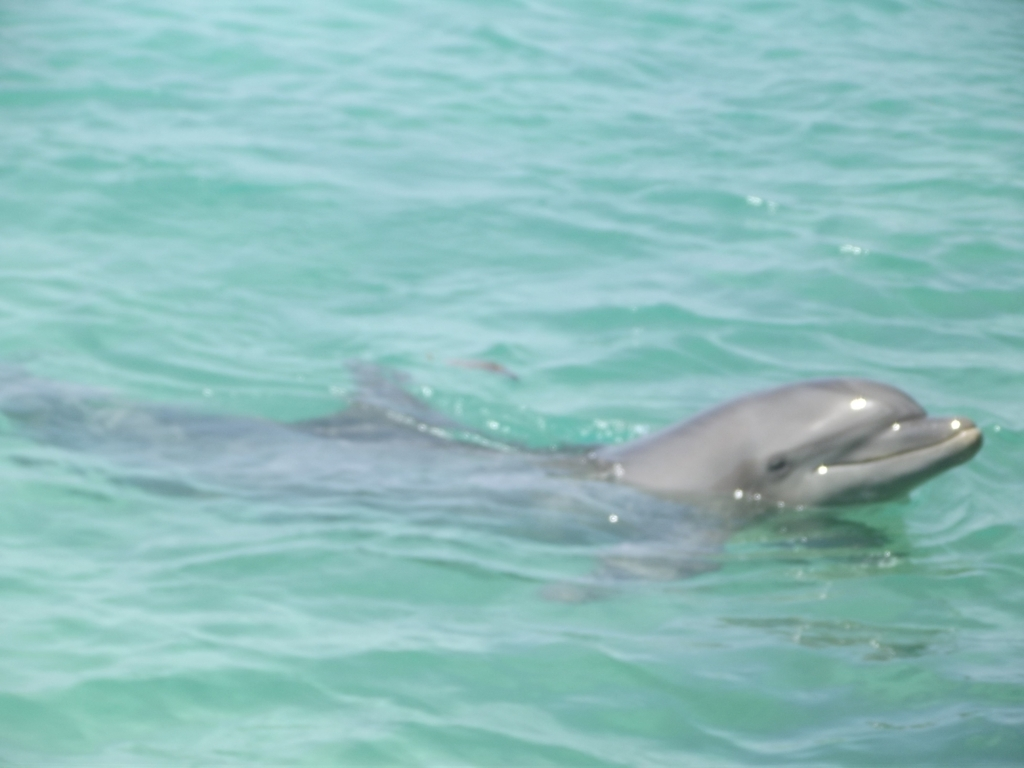What time of day do you think this photo was taken? Judging by the brightness and the quality of the light, it seems the photo was taken during the midday hours when the sun is quite high in the sky. This is when sunlight can be most direct and intense, which is consistent with the visible glare and the overexposed sections of the image. 